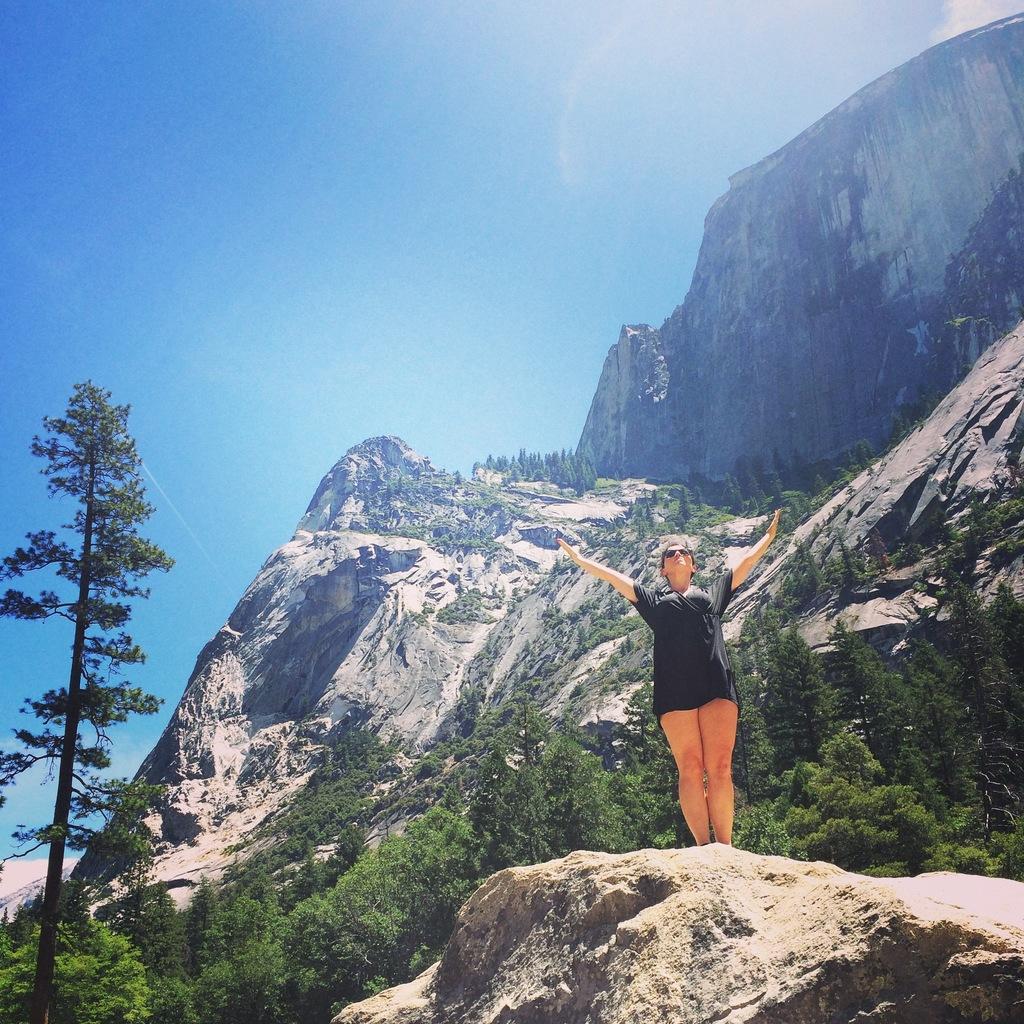Describe this image in one or two sentences. In the picture I can see a woman standing on the rock and she is wearing the black color clothes. In the background, I can see the mountains and trees. There are clouds in the sky. 